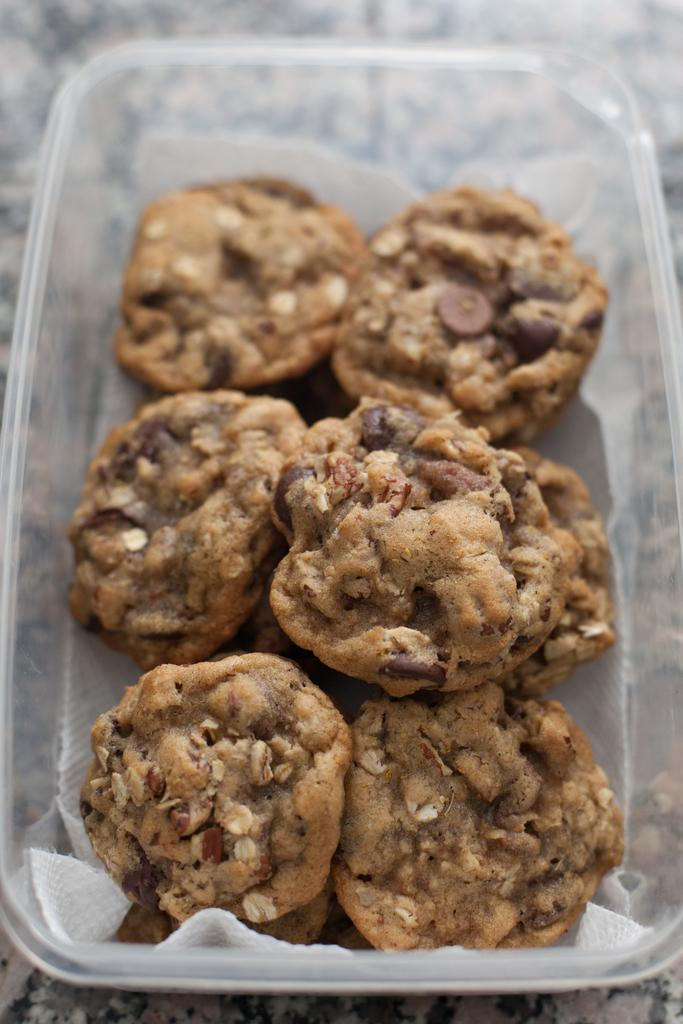What type of food can be seen in the image? There are cookies in the image. How are the cookies stored or contained in the image? The cookies are in a box. What type of ray is visible in the image? There is no ray present in the image; it features cookies in a box. What scientific theory can be observed in the image? There is no scientific theory depicted in the image; it features cookies in a box. 